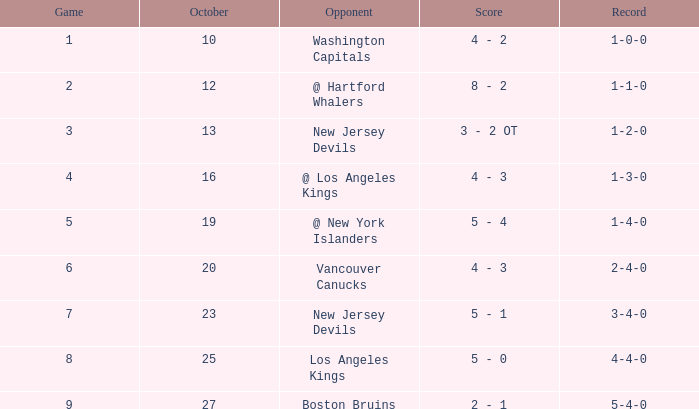Which game has the highest score in October with 9? 27.0. 